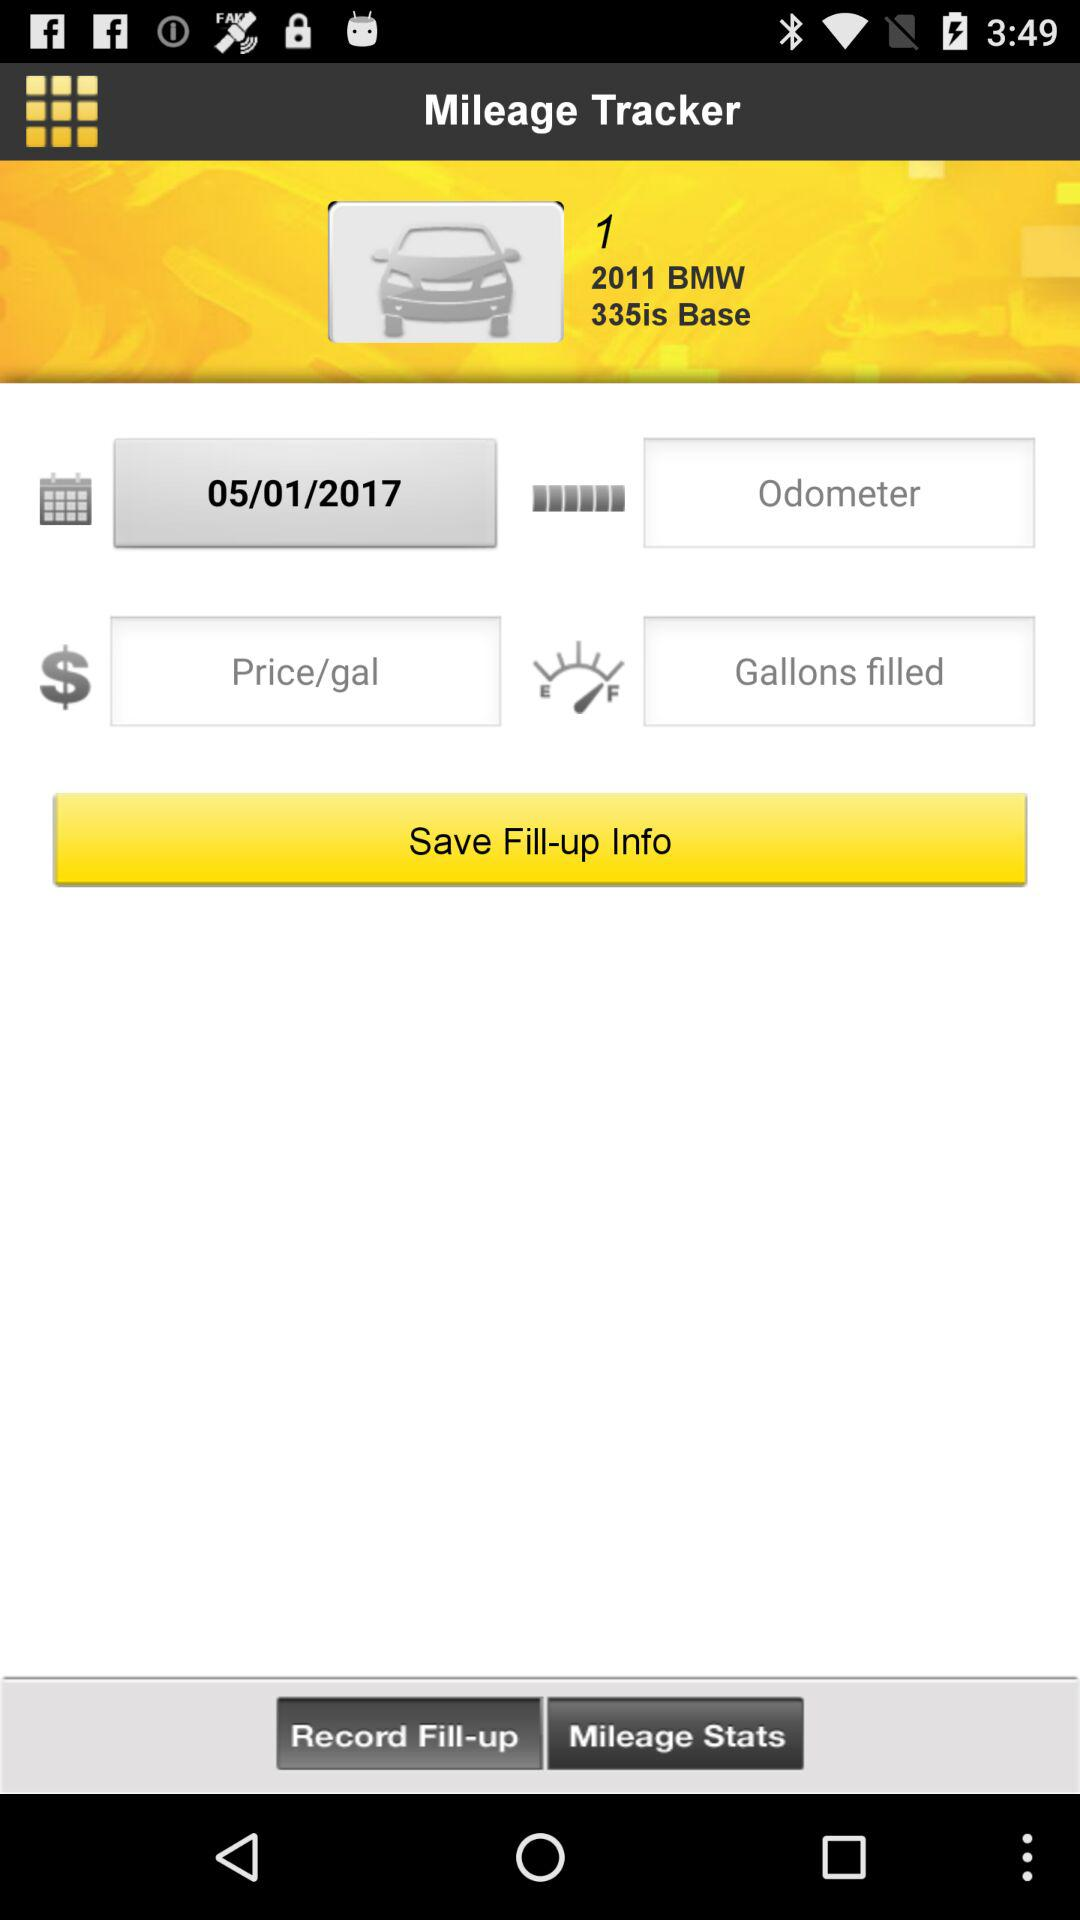What is the name of the application? The name of the application is "Mileage Tracker". 